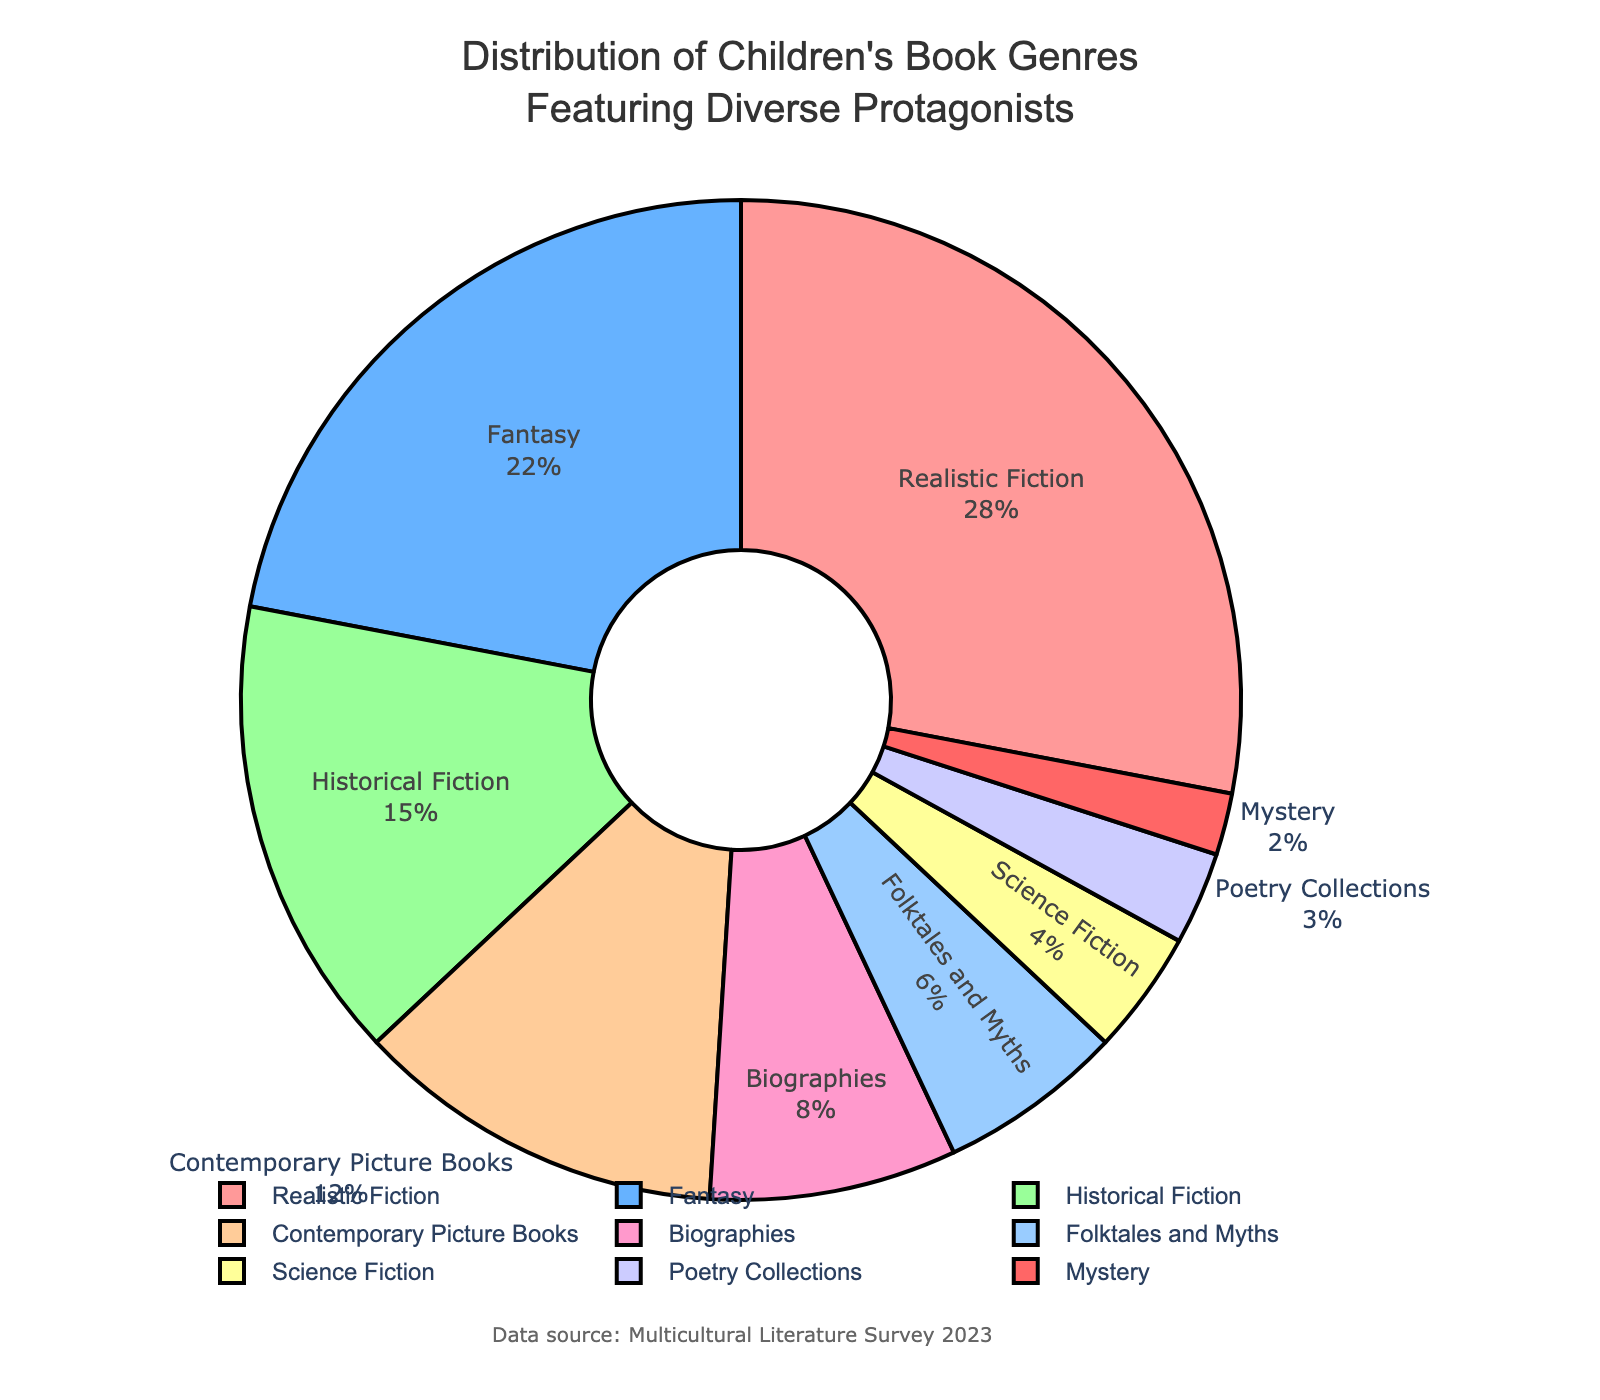Which genre has the lowest percentage of children's books featuring diverse protagonists? Looking at the pie chart, the smallest segment represents Mystery.
Answer: Mystery What is the total percentage of children's books featuring diverse protagonists in the genres of Realistic Fiction, Fantasy, and Historical Fiction? Sum the percentages of Realistic Fiction (28%), Fantasy (22%), and Historical Fiction (15%): 28 + 22 + 15 = 65%
Answer: 65% Compare the percentages of Contemporary Picture Books and Biographies. Which genre has a higher percentage, and by how much? Contemporary Picture Books have 12%, and Biographies have 8%. The difference is 12 - 8 = 4%. Contemporary Picture Books have a higher percentage by 4%.
Answer: Contemporary Picture Books by 4% Are there more children's books featuring diverse protagonists in Fantasy or Science Fiction, and by how much? Fantasy has 22%, and Science Fiction has 4%. The difference is 22 - 4 = 18%. There are more in Fantasy by 18%.
Answer: Fantasy by 18% What is the combined percentage of the genres that have a percentage below 10%? Sum the percentages of Biographies (8%), Folktales and Myths (6%), Science Fiction (4%), Poetry Collections (3%), and Mystery (2%): 8 + 6 + 4 + 3 + 2 = 23%
Answer: 23% Which genre has the largest percentage of children's books featuring diverse protagonists? The largest segment is labeled Realistic Fiction, with 28%.
Answer: Realistic Fiction How much more percentage do Realistic Fiction books account for compared to Poetry Collections? Realistic Fiction is 28%, and Poetry Collections are 3%. The difference is 28 - 3 = 25%.
Answer: 25% If you combine the percentages of Folktales and Myths and Science Fiction, do they exceed the percentage of Contemporary Picture Books? Folktales and Myths are 6%, and Science Fiction is 4%. Combined, they are 6 + 4 = 10%. Contemporary Picture Books are 12%. No, they do not exceed.
Answer: No What percentage of the total do the top three genres represent? The top three genres are Realistic Fiction (28%), Fantasy (22%), and Historical Fiction (15%). Combined, they are 28 + 22 + 15 = 65%.
Answer: 65% 